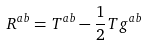Convert formula to latex. <formula><loc_0><loc_0><loc_500><loc_500>R ^ { a b } = T ^ { a b } - \frac { 1 } { 2 } T g ^ { a b }</formula> 